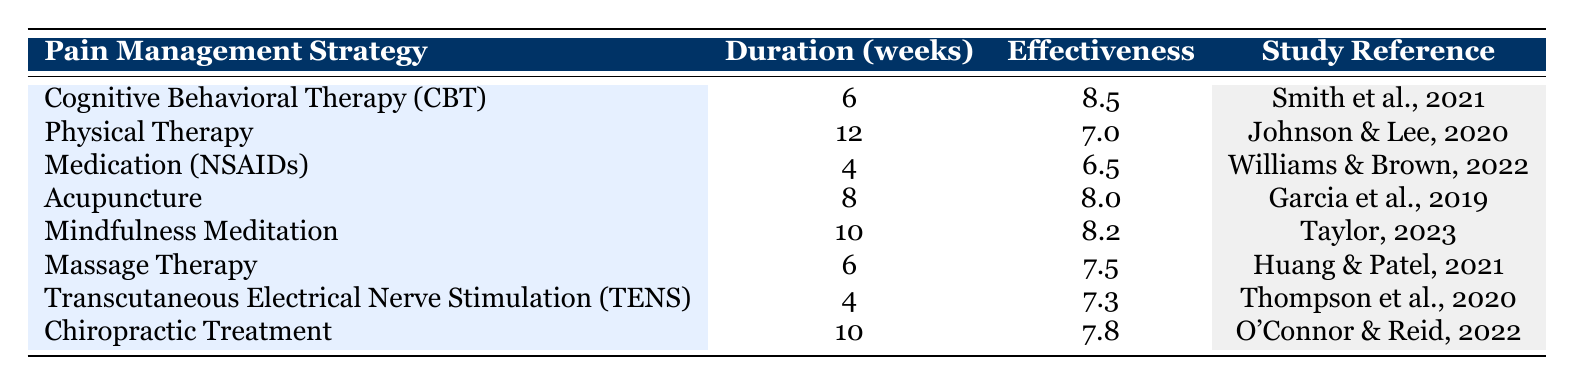What is the effectiveness rating of Cognitive Behavioral Therapy? The effectiveness rating for Cognitive Behavioral Therapy (CBT) is listed in the table under the "Effectiveness" column for the corresponding strategy. It shows a rating of 8.5.
Answer: 8.5 Which pain management strategy has the longest treatment duration? Looking at the "Duration (weeks)" column, Physical Therapy has the highest value at 12 weeks.
Answer: Physical Therapy How many strategies have an effectiveness rating above 7.5? I will review the "Effectiveness" column, counting those ratings that exceed 7.5. The strategies with ratings above 7.5 are CBT (8.5), Acupuncture (8.0), Mindfulness Meditation (8.2), and Massage Therapy (7.5). There are 3 strategies above 7.5 (excluding Massage Therapy).
Answer: 3 Is Medication (NSAIDs) the most effective pain management strategy? The effectiveness rating of Medication (NSAIDs) is 6.5. Comparing it with other strategies in the table, none have lower ratings; thus, it is not the most effective.
Answer: No What is the average effectiveness rating of all strategies with a treatment duration of 10 weeks? First, I'll identify the strategies with a treatment duration of 10 weeks from the table, which are Mindfulness Meditation (8.2) and Chiropractic Treatment (7.8). Next, I will sum their effectiveness ratings: 8.2 + 7.8 = 16.0. Finally, divide by the number of strategies (2): 16.0 / 2 = 8.0.
Answer: 8.0 Which strategy has a higher effectiveness rating: Acupuncture or Massage Therapy? The effectiveness rating for Acupuncture is 8.0, while for Massage Therapy it is 7.5. Comparing these two values, it is clear that Acupuncture has a higher rating.
Answer: Acupuncture How many strategies use a treatment duration of less than 6 weeks? Reviewing the "Duration (weeks)" column, the listed durations are: 6, 12, 4, 8, 10, 6, 4, and 10. Both Medication (NSAIDs) and Transcutaneous Electrical Nerve Stimulation (TENS) have durations of less than 6 weeks (4 weeks). Thus, there are 2 strategies that meet this criterion.
Answer: 2 What is the difference in effectiveness ratings between the most and least effective strategies? The most effective strategy is Cognitive Behavioral Therapy (CBT) with a rating of 8.5, and the least effective is Medication (NSAIDs) with a rating of 6.5. The difference is calculated as 8.5 - 6.5 = 2.0.
Answer: 2.0 